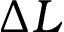Convert formula to latex. <formula><loc_0><loc_0><loc_500><loc_500>\Delta L</formula> 